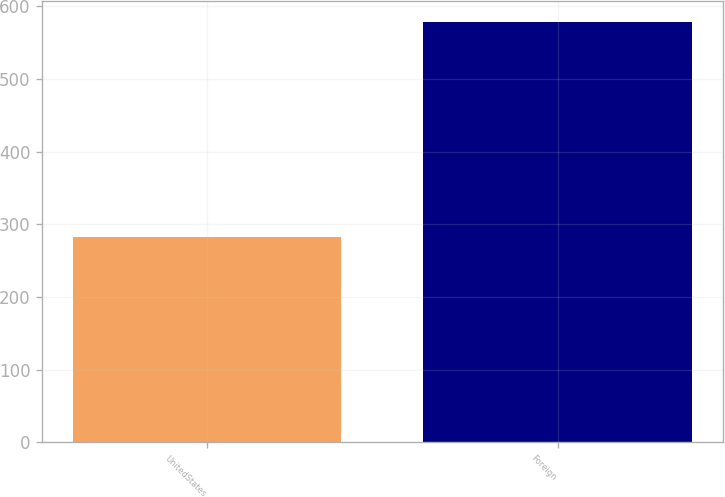Convert chart. <chart><loc_0><loc_0><loc_500><loc_500><bar_chart><fcel>UnitedStates<fcel>Foreign<nl><fcel>283<fcel>578<nl></chart> 